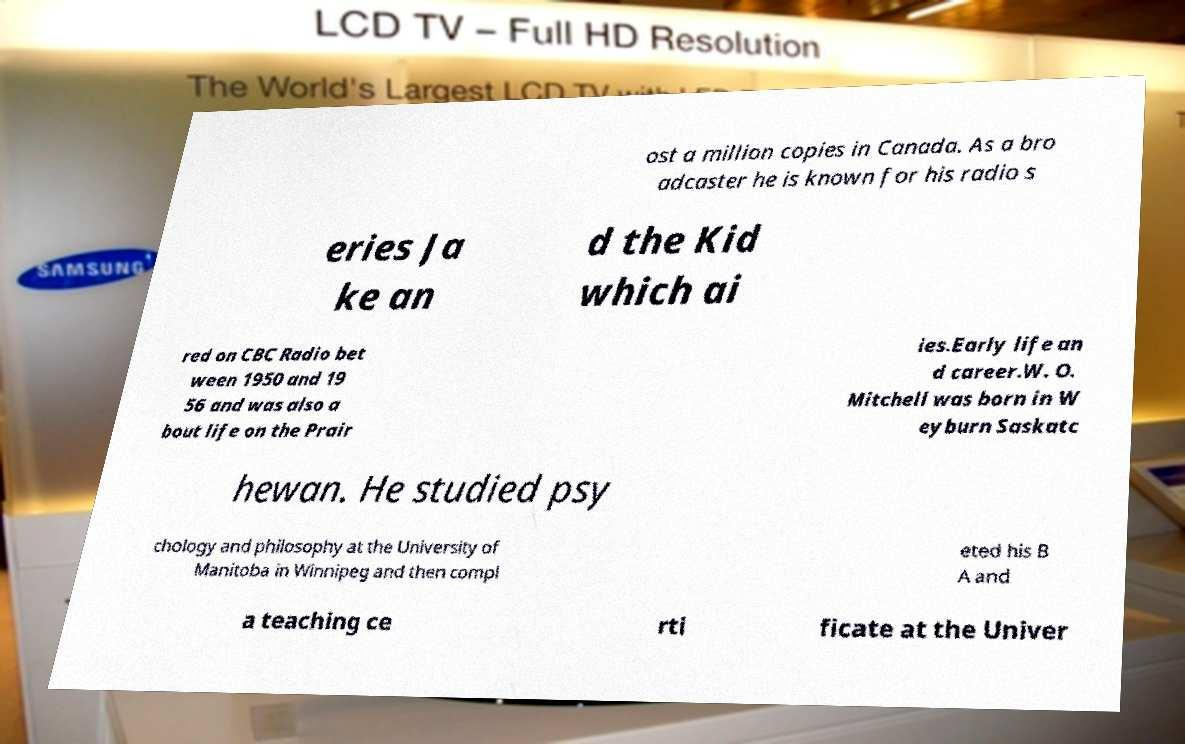Please read and relay the text visible in this image. What does it say? ost a million copies in Canada. As a bro adcaster he is known for his radio s eries Ja ke an d the Kid which ai red on CBC Radio bet ween 1950 and 19 56 and was also a bout life on the Prair ies.Early life an d career.W. O. Mitchell was born in W eyburn Saskatc hewan. He studied psy chology and philosophy at the University of Manitoba in Winnipeg and then compl eted his B A and a teaching ce rti ficate at the Univer 